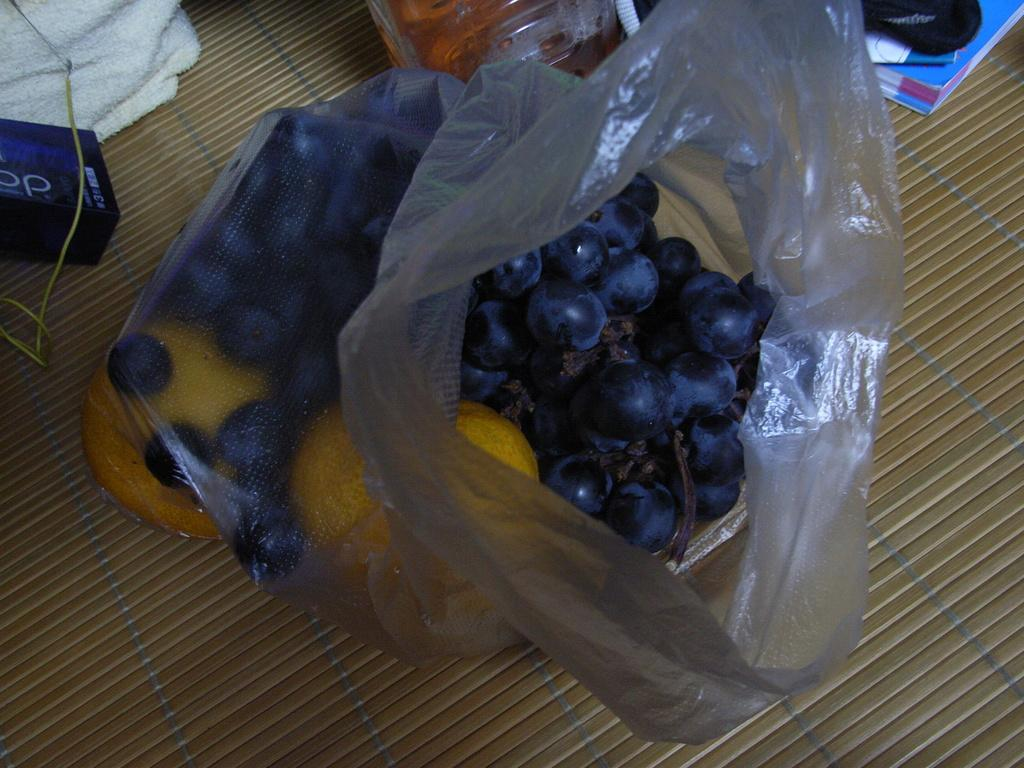What can be seen at the bottom of the image? The ground is visible in the image. What is covered and contains food items in the image? There are food items in a cover in the image. Where are objects located on the left side of the image? There are objects on the left side of the image. What type of material is visible in the image? There is cloth visible in the image. What is present at the top of the image? There are objects at the top of the image. What type of whistle can be heard in the image? There is no whistle present in the image, so it is not possible to hear any whistle. 